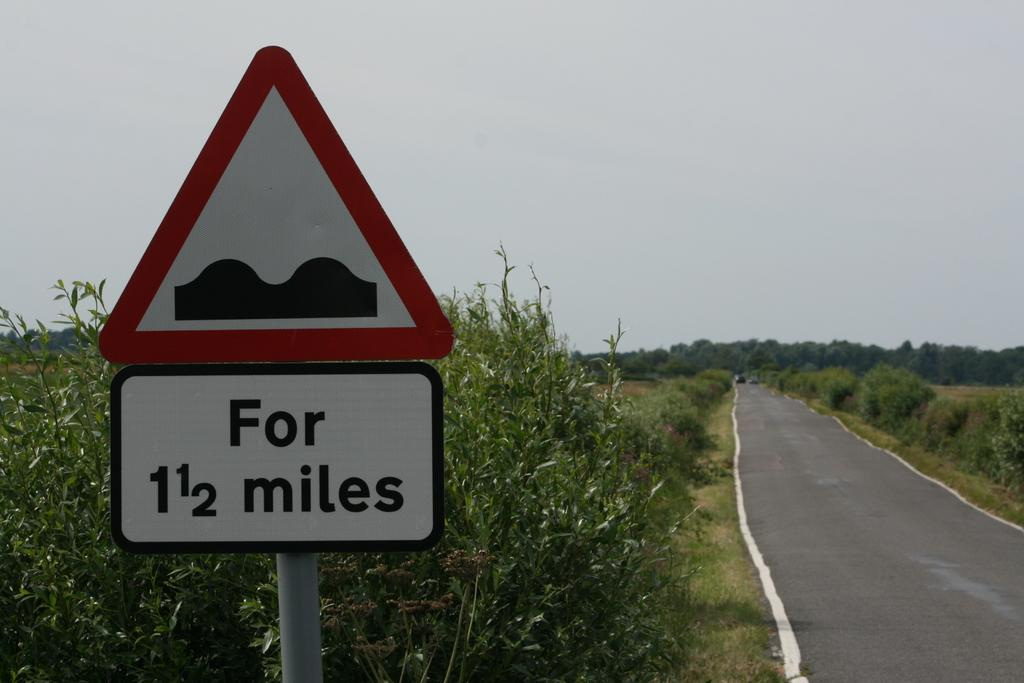<image>
Describe the image concisely. The road ahead is bumpy for the next mile and a half. 